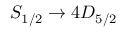Convert formula to latex. <formula><loc_0><loc_0><loc_500><loc_500>S _ { 1 / 2 } \rightarrow 4 D _ { 5 / 2 }</formula> 